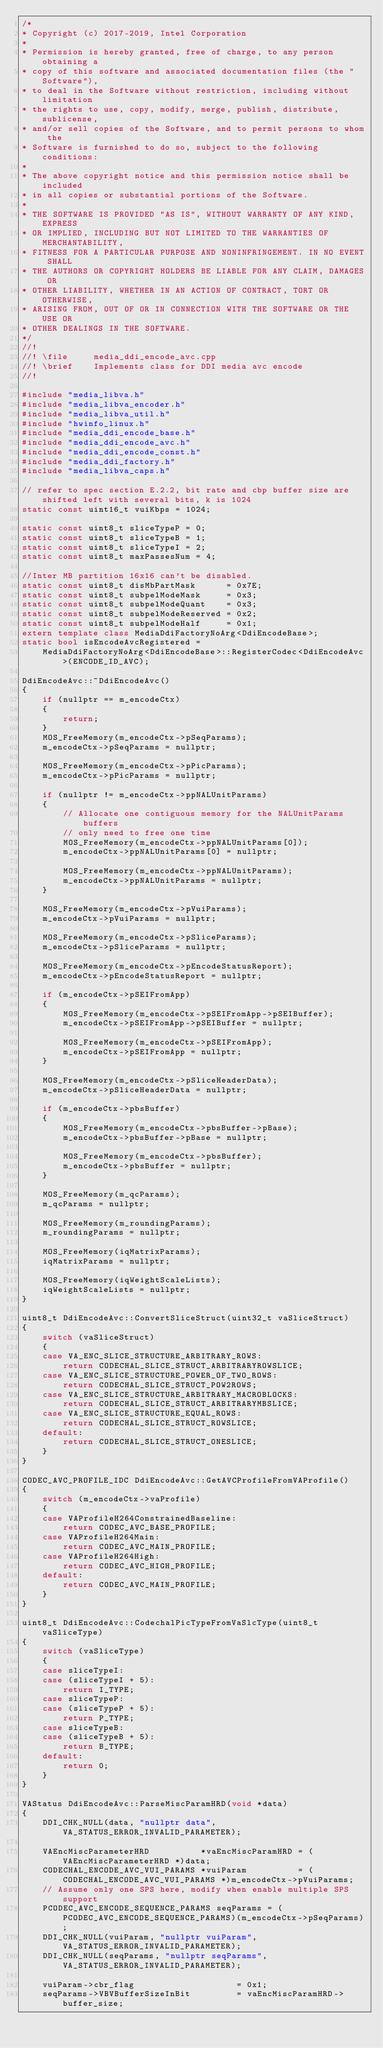Convert code to text. <code><loc_0><loc_0><loc_500><loc_500><_C++_>/*
* Copyright (c) 2017-2019, Intel Corporation
*
* Permission is hereby granted, free of charge, to any person obtaining a
* copy of this software and associated documentation files (the "Software"),
* to deal in the Software without restriction, including without limitation
* the rights to use, copy, modify, merge, publish, distribute, sublicense,
* and/or sell copies of the Software, and to permit persons to whom the
* Software is furnished to do so, subject to the following conditions:
*
* The above copyright notice and this permission notice shall be included
* in all copies or substantial portions of the Software.
*
* THE SOFTWARE IS PROVIDED "AS IS", WITHOUT WARRANTY OF ANY KIND, EXPRESS
* OR IMPLIED, INCLUDING BUT NOT LIMITED TO THE WARRANTIES OF MERCHANTABILITY,
* FITNESS FOR A PARTICULAR PURPOSE AND NONINFRINGEMENT. IN NO EVENT SHALL
* THE AUTHORS OR COPYRIGHT HOLDERS BE LIABLE FOR ANY CLAIM, DAMAGES OR
* OTHER LIABILITY, WHETHER IN AN ACTION OF CONTRACT, TORT OR OTHERWISE,
* ARISING FROM, OUT OF OR IN CONNECTION WITH THE SOFTWARE OR THE USE OR
* OTHER DEALINGS IN THE SOFTWARE.
*/
//!
//! \file     media_ddi_encode_avc.cpp
//! \brief    Implements class for DDI media avc encode
//!

#include "media_libva.h"
#include "media_libva_encoder.h"
#include "media_libva_util.h"
#include "hwinfo_linux.h"
#include "media_ddi_encode_base.h"
#include "media_ddi_encode_avc.h"
#include "media_ddi_encode_const.h"
#include "media_ddi_factory.h"
#include "media_libva_caps.h"

// refer to spec section E.2.2, bit rate and cbp buffer size are shifted left with several bits, k is 1024
static const uint16_t vuiKbps = 1024;

static const uint8_t sliceTypeP = 0;
static const uint8_t sliceTypeB = 1;
static const uint8_t sliceTypeI = 2;
static const uint8_t maxPassesNum = 4;

//Inter MB partition 16x16 can't be disabled.
static const uint8_t disMbPartMask      = 0x7E;
static const uint8_t subpelModeMask     = 0x3;
static const uint8_t subpelModeQuant    = 0x3;
static const uint8_t subpelModeReserved = 0x2;
static const uint8_t subpelModeHalf     = 0x1;
extern template class MediaDdiFactoryNoArg<DdiEncodeBase>;
static bool isEncodeAvcRegistered =
    MediaDdiFactoryNoArg<DdiEncodeBase>::RegisterCodec<DdiEncodeAvc>(ENCODE_ID_AVC);

DdiEncodeAvc::~DdiEncodeAvc()
{
    if (nullptr == m_encodeCtx)
    {
        return;
    }
    MOS_FreeMemory(m_encodeCtx->pSeqParams);
    m_encodeCtx->pSeqParams = nullptr;

    MOS_FreeMemory(m_encodeCtx->pPicParams);
    m_encodeCtx->pPicParams = nullptr;

    if (nullptr != m_encodeCtx->ppNALUnitParams)
    {
        // Allocate one contiguous memory for the NALUnitParams buffers
        // only need to free one time
        MOS_FreeMemory(m_encodeCtx->ppNALUnitParams[0]);
        m_encodeCtx->ppNALUnitParams[0] = nullptr;

        MOS_FreeMemory(m_encodeCtx->ppNALUnitParams);
        m_encodeCtx->ppNALUnitParams = nullptr;
    }

    MOS_FreeMemory(m_encodeCtx->pVuiParams);
    m_encodeCtx->pVuiParams = nullptr;

    MOS_FreeMemory(m_encodeCtx->pSliceParams);
    m_encodeCtx->pSliceParams = nullptr;

    MOS_FreeMemory(m_encodeCtx->pEncodeStatusReport);
    m_encodeCtx->pEncodeStatusReport = nullptr;

    if (m_encodeCtx->pSEIFromApp)
    {
        MOS_FreeMemory(m_encodeCtx->pSEIFromApp->pSEIBuffer);
        m_encodeCtx->pSEIFromApp->pSEIBuffer = nullptr;

        MOS_FreeMemory(m_encodeCtx->pSEIFromApp);
        m_encodeCtx->pSEIFromApp = nullptr;
    }

    MOS_FreeMemory(m_encodeCtx->pSliceHeaderData);
    m_encodeCtx->pSliceHeaderData = nullptr;

    if (m_encodeCtx->pbsBuffer)
    {
        MOS_FreeMemory(m_encodeCtx->pbsBuffer->pBase);
        m_encodeCtx->pbsBuffer->pBase = nullptr;

        MOS_FreeMemory(m_encodeCtx->pbsBuffer);
        m_encodeCtx->pbsBuffer = nullptr;
    }

    MOS_FreeMemory(m_qcParams);
    m_qcParams = nullptr;

    MOS_FreeMemory(m_roundingParams);
    m_roundingParams = nullptr;

    MOS_FreeMemory(iqMatrixParams);
    iqMatrixParams = nullptr;

    MOS_FreeMemory(iqWeightScaleLists);
    iqWeightScaleLists = nullptr;
}

uint8_t DdiEncodeAvc::ConvertSliceStruct(uint32_t vaSliceStruct)
{
    switch (vaSliceStruct)
    {
    case VA_ENC_SLICE_STRUCTURE_ARBITRARY_ROWS:
        return CODECHAL_SLICE_STRUCT_ARBITRARYROWSLICE;
    case VA_ENC_SLICE_STRUCTURE_POWER_OF_TWO_ROWS:
        return CODECHAL_SLICE_STRUCT_POW2ROWS;
    case VA_ENC_SLICE_STRUCTURE_ARBITRARY_MACROBLOCKS:
        return CODECHAL_SLICE_STRUCT_ARBITRARYMBSLICE;
    case VA_ENC_SLICE_STRUCTURE_EQUAL_ROWS:
        return CODECHAL_SLICE_STRUCT_ROWSLICE;
    default:
        return CODECHAL_SLICE_STRUCT_ONESLICE;
    }
}

CODEC_AVC_PROFILE_IDC DdiEncodeAvc::GetAVCProfileFromVAProfile()
{
    switch (m_encodeCtx->vaProfile)
    {
    case VAProfileH264ConstrainedBaseline:
        return CODEC_AVC_BASE_PROFILE;
    case VAProfileH264Main:
        return CODEC_AVC_MAIN_PROFILE;
    case VAProfileH264High:
        return CODEC_AVC_HIGH_PROFILE;
    default:
        return CODEC_AVC_MAIN_PROFILE;
    }
}

uint8_t DdiEncodeAvc::CodechalPicTypeFromVaSlcType(uint8_t vaSliceType)
{
    switch (vaSliceType)
    {
    case sliceTypeI:
    case (sliceTypeI + 5):
        return I_TYPE;
    case sliceTypeP:
    case (sliceTypeP + 5):
        return P_TYPE;
    case sliceTypeB:
    case (sliceTypeB + 5):
        return B_TYPE;
    default:
        return 0;
    }
}

VAStatus DdiEncodeAvc::ParseMiscParamHRD(void *data)
{
    DDI_CHK_NULL(data, "nullptr data", VA_STATUS_ERROR_INVALID_PARAMETER);

    VAEncMiscParameterHRD          *vaEncMiscParamHRD = (VAEncMiscParameterHRD *)data;
    CODECHAL_ENCODE_AVC_VUI_PARAMS *vuiParam          = (CODECHAL_ENCODE_AVC_VUI_PARAMS *)m_encodeCtx->pVuiParams;
    // Assume only one SPS here, modify when enable multiple SPS support
    PCODEC_AVC_ENCODE_SEQUENCE_PARAMS seqParams = (PCODEC_AVC_ENCODE_SEQUENCE_PARAMS)(m_encodeCtx->pSeqParams);
    DDI_CHK_NULL(vuiParam, "nullptr vuiParam", VA_STATUS_ERROR_INVALID_PARAMETER);
    DDI_CHK_NULL(seqParams, "nullptr seqParams", VA_STATUS_ERROR_INVALID_PARAMETER);

    vuiParam->cbr_flag                    = 0x1;
    seqParams->VBVBufferSizeInBit         = vaEncMiscParamHRD->buffer_size;</code> 